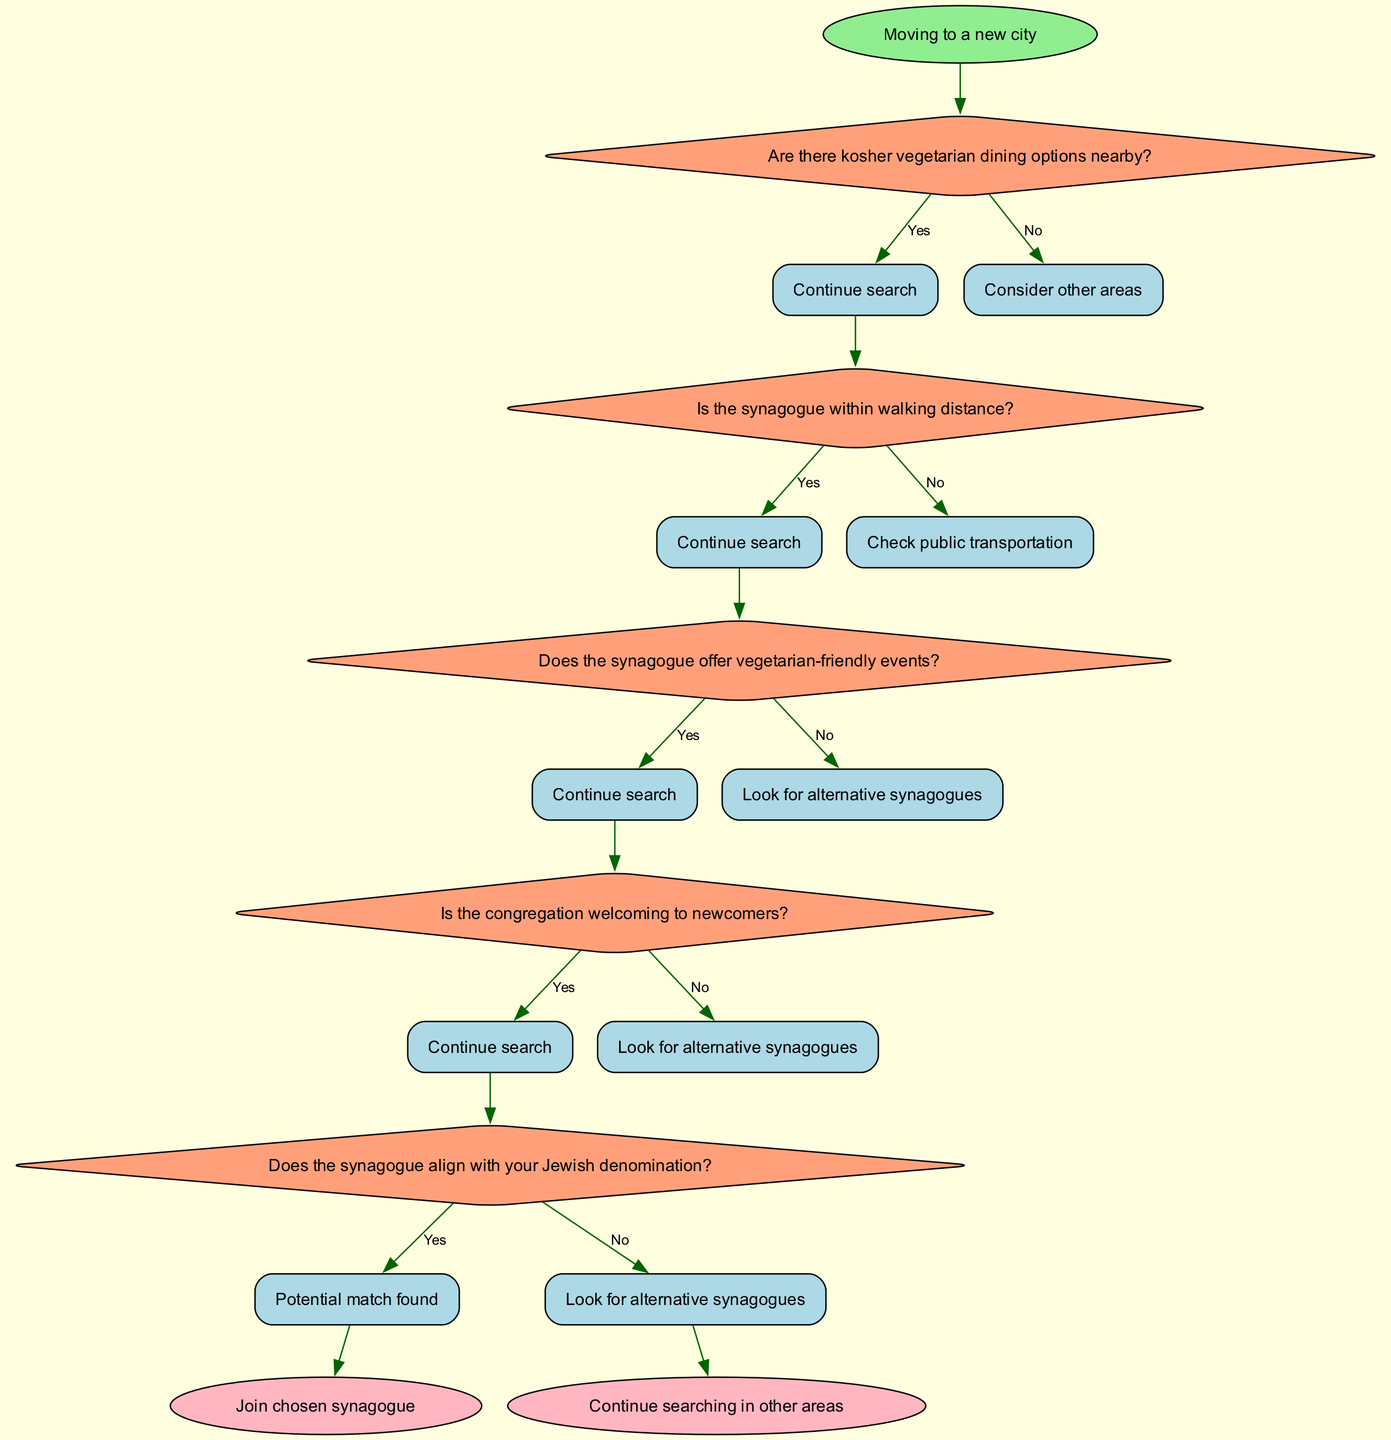What is the first decision in the flowchart? The first decision in the flowchart is about kosher vegetarian dining options. It directly follows the start node, indicating that this is the first consideration when choosing a synagogue in a new city.
Answer: Are there kosher vegetarian dining options nearby? How many decisions are present in the flowchart? The flowchart contains five decision points, each pertaining to different aspects of choosing a synagogue. This can be determined by counting each decision node listed in the data.
Answer: Five What happens if the answer to "Is the congregation welcoming to newcomers?" is no? If the answer is no to this question, the flowchart indicates that the next step is to look for alternative synagogues, as welcoming congregations are a priority for decision making.
Answer: Look for alternative synagogues Does the flowchart indicate a specific Jewish denomination preference? Yes, the flowchart includes a decision node asking if the synagogue aligns with your Jewish denomination, highlighting the importance of denomination in the decision-making process.
Answer: Yes What is the outcome if all decisions are answered with yes? If all decisions along the flowchart path are answered with yes, it leads to the conclusion of joining the chosen synagogue, confirming a suitable match based on the parameters set out in the flowchart.
Answer: Join chosen synagogue What does the flowchart suggest if there are no kosher vegetarian options nearby? The flowchart suggests considering other areas if there are no kosher vegetarian dining options nearby, indicating that access to suitable food options is crucial in the decision process.
Answer: Consider other areas What indicates a potential match in the decision-making process? A potential match in the decision-making process is indicated by answering yes to the question regarding alignment with your Jewish denomination, signifying that if this condition is met, a suitable synagogue may be found.
Answer: Potential match found What is the final outcome if the last decision is answered with no? If the last decision about Jewish denomination alignment is answered with no, the flowchart leads to looking for alternative synagogues, emphasizing the necessity of this alignment in making a decision.
Answer: Look for alternative synagogues 